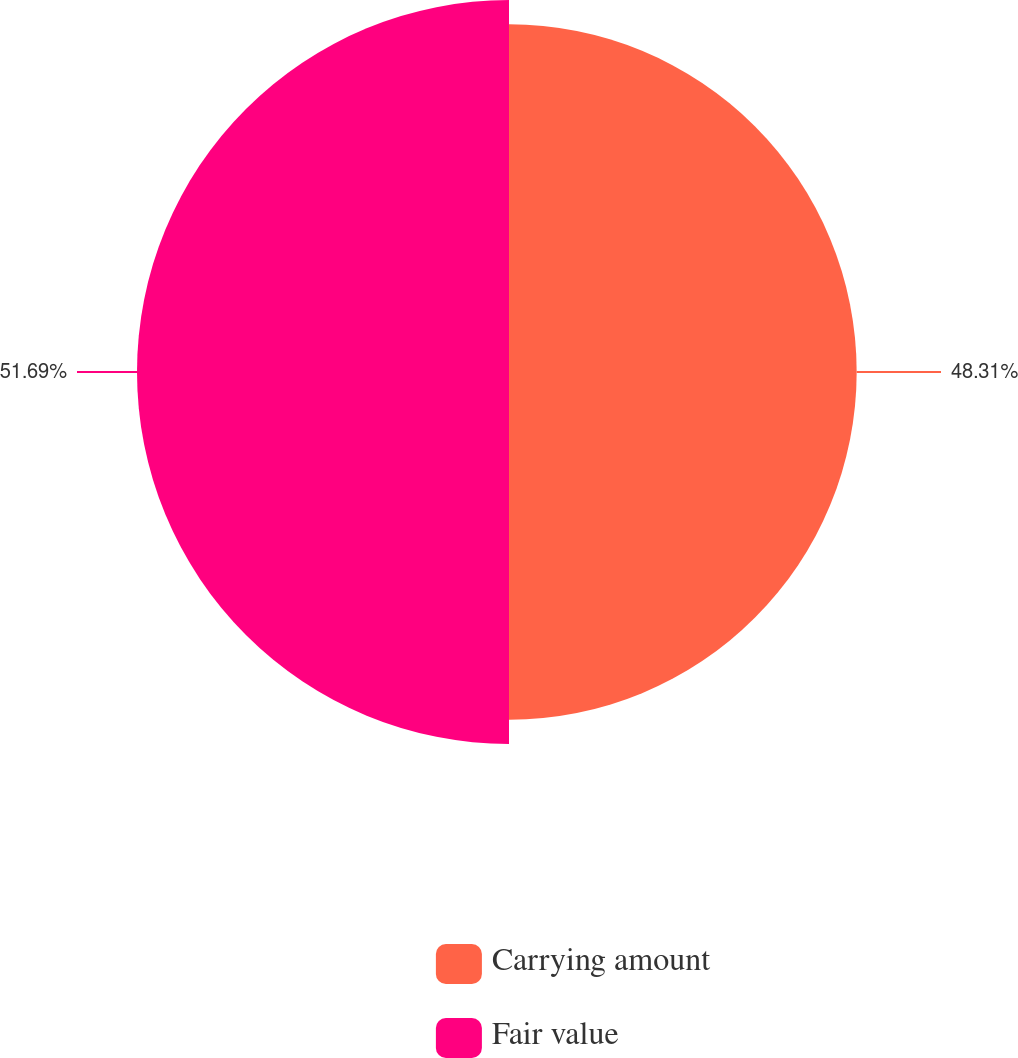Convert chart to OTSL. <chart><loc_0><loc_0><loc_500><loc_500><pie_chart><fcel>Carrying amount<fcel>Fair value<nl><fcel>48.31%<fcel>51.69%<nl></chart> 